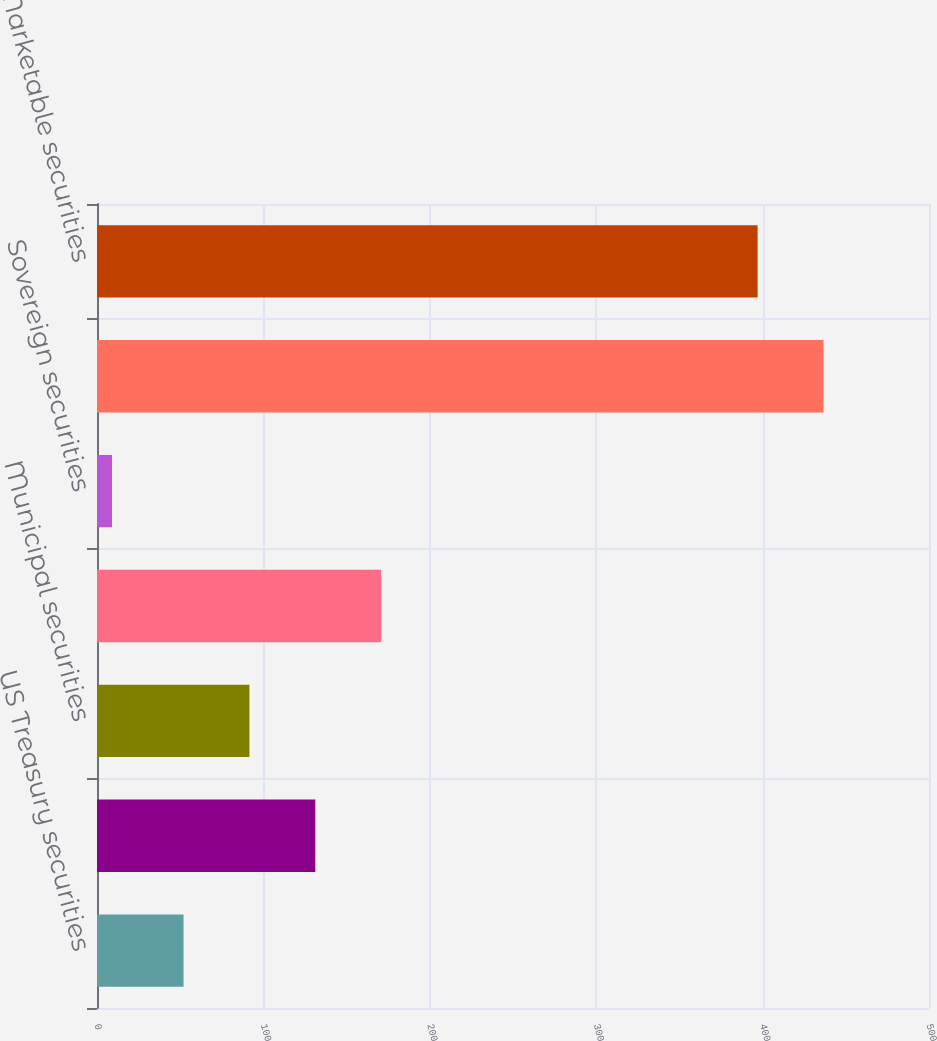Convert chart. <chart><loc_0><loc_0><loc_500><loc_500><bar_chart><fcel>US Treasury securities<fcel>US Government agency<fcel>Municipal securities<fcel>Corporate debt securities<fcel>Sovereign securities<fcel>Subtotal<fcel>Marketable securities<nl><fcel>52<fcel>131.2<fcel>91.6<fcel>170.8<fcel>9<fcel>436.6<fcel>397<nl></chart> 